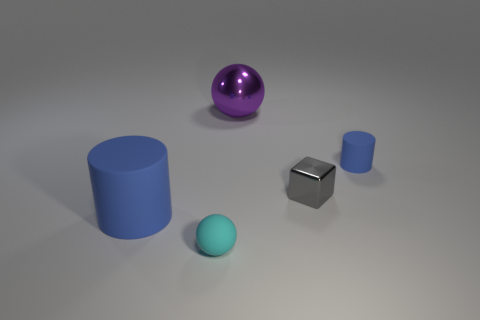What shape is the tiny blue object? cylinder 